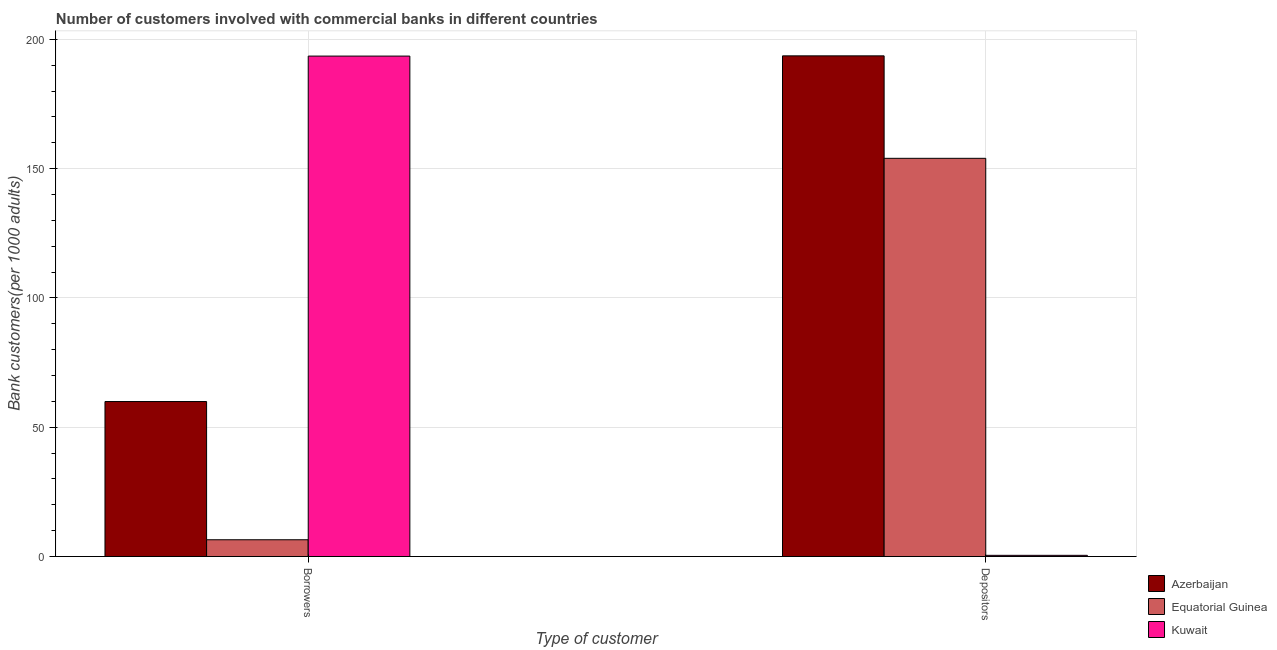Are the number of bars per tick equal to the number of legend labels?
Offer a terse response. Yes. Are the number of bars on each tick of the X-axis equal?
Ensure brevity in your answer.  Yes. How many bars are there on the 1st tick from the right?
Your response must be concise. 3. What is the label of the 1st group of bars from the left?
Give a very brief answer. Borrowers. What is the number of borrowers in Equatorial Guinea?
Your response must be concise. 6.49. Across all countries, what is the maximum number of borrowers?
Your response must be concise. 193.5. Across all countries, what is the minimum number of borrowers?
Offer a very short reply. 6.49. In which country was the number of borrowers maximum?
Provide a succinct answer. Kuwait. In which country was the number of borrowers minimum?
Provide a short and direct response. Equatorial Guinea. What is the total number of borrowers in the graph?
Make the answer very short. 259.92. What is the difference between the number of borrowers in Kuwait and that in Equatorial Guinea?
Provide a succinct answer. 187.01. What is the difference between the number of borrowers in Kuwait and the number of depositors in Azerbaijan?
Offer a very short reply. -0.09. What is the average number of depositors per country?
Your answer should be compact. 116.01. What is the difference between the number of depositors and number of borrowers in Equatorial Guinea?
Your response must be concise. 147.48. In how many countries, is the number of depositors greater than 140 ?
Your response must be concise. 2. What is the ratio of the number of depositors in Equatorial Guinea to that in Azerbaijan?
Offer a terse response. 0.8. In how many countries, is the number of borrowers greater than the average number of borrowers taken over all countries?
Offer a very short reply. 1. What does the 3rd bar from the left in Borrowers represents?
Your answer should be very brief. Kuwait. What does the 1st bar from the right in Depositors represents?
Give a very brief answer. Kuwait. Are all the bars in the graph horizontal?
Keep it short and to the point. No. How many countries are there in the graph?
Give a very brief answer. 3. What is the difference between two consecutive major ticks on the Y-axis?
Provide a succinct answer. 50. Are the values on the major ticks of Y-axis written in scientific E-notation?
Your answer should be compact. No. Does the graph contain any zero values?
Give a very brief answer. No. Where does the legend appear in the graph?
Your answer should be very brief. Bottom right. What is the title of the graph?
Give a very brief answer. Number of customers involved with commercial banks in different countries. What is the label or title of the X-axis?
Provide a succinct answer. Type of customer. What is the label or title of the Y-axis?
Provide a short and direct response. Bank customers(per 1000 adults). What is the Bank customers(per 1000 adults) of Azerbaijan in Borrowers?
Provide a short and direct response. 59.93. What is the Bank customers(per 1000 adults) in Equatorial Guinea in Borrowers?
Ensure brevity in your answer.  6.49. What is the Bank customers(per 1000 adults) in Kuwait in Borrowers?
Ensure brevity in your answer.  193.5. What is the Bank customers(per 1000 adults) in Azerbaijan in Depositors?
Your answer should be very brief. 193.59. What is the Bank customers(per 1000 adults) in Equatorial Guinea in Depositors?
Provide a succinct answer. 153.97. What is the Bank customers(per 1000 adults) in Kuwait in Depositors?
Your answer should be very brief. 0.46. Across all Type of customer, what is the maximum Bank customers(per 1000 adults) of Azerbaijan?
Offer a very short reply. 193.59. Across all Type of customer, what is the maximum Bank customers(per 1000 adults) in Equatorial Guinea?
Offer a terse response. 153.97. Across all Type of customer, what is the maximum Bank customers(per 1000 adults) in Kuwait?
Give a very brief answer. 193.5. Across all Type of customer, what is the minimum Bank customers(per 1000 adults) of Azerbaijan?
Provide a succinct answer. 59.93. Across all Type of customer, what is the minimum Bank customers(per 1000 adults) in Equatorial Guinea?
Your answer should be compact. 6.49. Across all Type of customer, what is the minimum Bank customers(per 1000 adults) in Kuwait?
Provide a succinct answer. 0.46. What is the total Bank customers(per 1000 adults) in Azerbaijan in the graph?
Offer a terse response. 253.52. What is the total Bank customers(per 1000 adults) in Equatorial Guinea in the graph?
Make the answer very short. 160.46. What is the total Bank customers(per 1000 adults) in Kuwait in the graph?
Give a very brief answer. 193.96. What is the difference between the Bank customers(per 1000 adults) of Azerbaijan in Borrowers and that in Depositors?
Give a very brief answer. -133.66. What is the difference between the Bank customers(per 1000 adults) of Equatorial Guinea in Borrowers and that in Depositors?
Your response must be concise. -147.48. What is the difference between the Bank customers(per 1000 adults) of Kuwait in Borrowers and that in Depositors?
Ensure brevity in your answer.  193.03. What is the difference between the Bank customers(per 1000 adults) in Azerbaijan in Borrowers and the Bank customers(per 1000 adults) in Equatorial Guinea in Depositors?
Offer a very short reply. -94.04. What is the difference between the Bank customers(per 1000 adults) of Azerbaijan in Borrowers and the Bank customers(per 1000 adults) of Kuwait in Depositors?
Your response must be concise. 59.47. What is the difference between the Bank customers(per 1000 adults) in Equatorial Guinea in Borrowers and the Bank customers(per 1000 adults) in Kuwait in Depositors?
Make the answer very short. 6.02. What is the average Bank customers(per 1000 adults) of Azerbaijan per Type of customer?
Offer a very short reply. 126.76. What is the average Bank customers(per 1000 adults) in Equatorial Guinea per Type of customer?
Your answer should be compact. 80.23. What is the average Bank customers(per 1000 adults) of Kuwait per Type of customer?
Offer a very short reply. 96.98. What is the difference between the Bank customers(per 1000 adults) of Azerbaijan and Bank customers(per 1000 adults) of Equatorial Guinea in Borrowers?
Keep it short and to the point. 53.44. What is the difference between the Bank customers(per 1000 adults) in Azerbaijan and Bank customers(per 1000 adults) in Kuwait in Borrowers?
Provide a short and direct response. -133.57. What is the difference between the Bank customers(per 1000 adults) in Equatorial Guinea and Bank customers(per 1000 adults) in Kuwait in Borrowers?
Ensure brevity in your answer.  -187.01. What is the difference between the Bank customers(per 1000 adults) in Azerbaijan and Bank customers(per 1000 adults) in Equatorial Guinea in Depositors?
Make the answer very short. 39.62. What is the difference between the Bank customers(per 1000 adults) of Azerbaijan and Bank customers(per 1000 adults) of Kuwait in Depositors?
Offer a terse response. 193.12. What is the difference between the Bank customers(per 1000 adults) in Equatorial Guinea and Bank customers(per 1000 adults) in Kuwait in Depositors?
Make the answer very short. 153.51. What is the ratio of the Bank customers(per 1000 adults) in Azerbaijan in Borrowers to that in Depositors?
Provide a short and direct response. 0.31. What is the ratio of the Bank customers(per 1000 adults) in Equatorial Guinea in Borrowers to that in Depositors?
Provide a succinct answer. 0.04. What is the ratio of the Bank customers(per 1000 adults) in Kuwait in Borrowers to that in Depositors?
Give a very brief answer. 416.98. What is the difference between the highest and the second highest Bank customers(per 1000 adults) in Azerbaijan?
Your response must be concise. 133.66. What is the difference between the highest and the second highest Bank customers(per 1000 adults) of Equatorial Guinea?
Your response must be concise. 147.48. What is the difference between the highest and the second highest Bank customers(per 1000 adults) of Kuwait?
Your answer should be compact. 193.03. What is the difference between the highest and the lowest Bank customers(per 1000 adults) of Azerbaijan?
Ensure brevity in your answer.  133.66. What is the difference between the highest and the lowest Bank customers(per 1000 adults) in Equatorial Guinea?
Your answer should be compact. 147.48. What is the difference between the highest and the lowest Bank customers(per 1000 adults) of Kuwait?
Your answer should be compact. 193.03. 